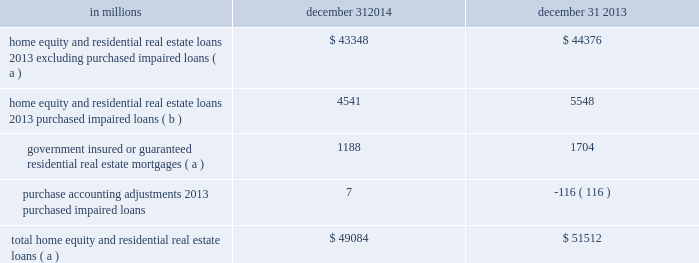Consumer lending asset classes home equity and residential real estate loan classes we use several credit quality indicators , including delinquency information , nonperforming loan information , updated credit scores , originated and updated ltv ratios , and geography , to monitor and manage credit risk within the home equity and residential real estate loan classes .
We evaluate mortgage loan performance by source originators and loan servicers .
A summary of asset quality indicators follows : delinquency/delinquency rates : we monitor trending of delinquency/delinquency rates for home equity and residential real estate loans .
See the asset quality section of this note 3 for additional information .
Nonperforming loans : we monitor trending of nonperforming loans for home equity and residential real estate loans .
See the asset quality section of this note 3 for additional information .
Credit scores : we use a national third-party provider to update fico credit scores for home equity loans and lines of credit and residential real estate loans at least quarterly .
The updated scores are incorporated into a series of credit management reports , which are utilized to monitor the risk in the loan classes .
Ltv ( inclusive of combined loan-to-value ( cltv ) for first and subordinate lien positions ) : at least annually , we update the property values of real estate collateral and calculate an updated ltv ratio .
For open-end credit lines secured by real estate in regions experiencing significant declines in property values , more frequent valuations may occur .
We examine ltv migration and stratify ltv into categories to monitor the risk in the loan classes .
Historically , we used , and we continue to use , a combination of original ltv and updated ltv for internal risk management and reporting purposes ( e.g. , line management , loss mitigation strategies ) .
In addition to the fact that estimated property values by their nature are estimates , given certain data limitations it is important to note that updated ltvs may be based upon management 2019s assumptions ( e.g. , if an updated ltv is not provided by the third-party service provider , home price index ( hpi ) changes will be incorporated in arriving at management 2019s estimate of updated ltv ) .
Geography : geographic concentrations are monitored to evaluate and manage exposures .
Loan purchase programs are sensitive to , and focused within , certain regions to manage geographic exposures and associated risks .
A combination of updated fico scores , originated and updated ltv ratios and geographic location assigned to home equity loans and lines of credit and residential real estate loans is used to monitor the risk in the loan classes .
Loans with higher fico scores and lower ltvs tend to have a lower level of risk .
Conversely , loans with lower fico scores , higher ltvs , and in certain geographic locations tend to have a higher level of risk .
Consumer purchased impaired loan class estimates of the expected cash flows primarily determine the valuation of consumer purchased impaired loans .
Consumer cash flow estimates are influenced by a number of credit related items , which include , but are not limited to : estimated real estate values , payment patterns , updated fico scores , the current economic environment , updated ltv ratios and the date of origination .
These key factors are monitored to help ensure that concentrations of risk are managed and cash flows are maximized .
See note 4 purchased loans for additional information .
Table 63 : home equity and residential real estate balances in millions december 31 december 31 .
( a ) represents recorded investment .
( b ) represents outstanding balance .
The pnc financial services group , inc .
2013 form 10-k 133 .
What percentage of the total home equity and real estate loans in 2014 explicitly excluded purchased impaired loans? 
Computations: (43348 / 49084)
Answer: 0.88314. 